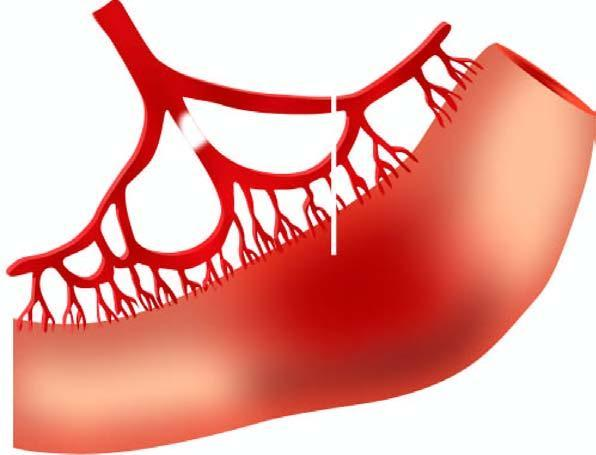s line of demarcation between gangrenous segment and the viable bowel soft, swollen and dark?
Answer the question using a single word or phrase. No 